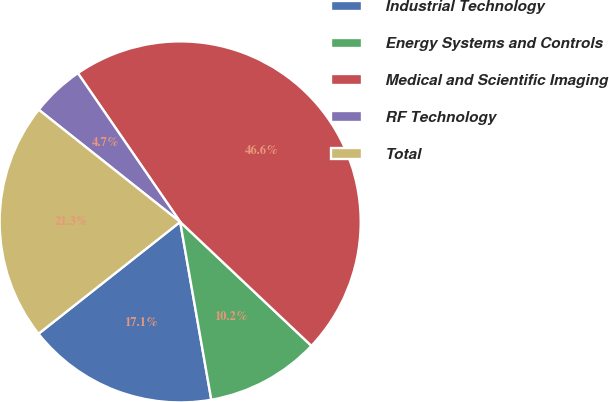Convert chart to OTSL. <chart><loc_0><loc_0><loc_500><loc_500><pie_chart><fcel>Industrial Technology<fcel>Energy Systems and Controls<fcel>Medical and Scientific Imaging<fcel>RF Technology<fcel>Total<nl><fcel>17.12%<fcel>10.2%<fcel>46.63%<fcel>4.74%<fcel>21.31%<nl></chart> 